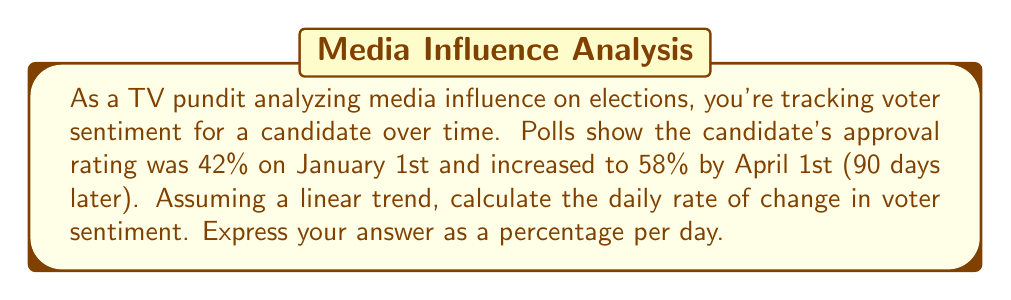Solve this math problem. To solve this problem, we'll use the concept of linear functions and rate of change. Let's break it down step-by-step:

1. Identify the given information:
   - Initial approval rating: 42% on January 1st
   - Final approval rating: 58% on April 1st
   - Time period: 90 days

2. Calculate the total change in approval rating:
   $\Delta y = 58\% - 42\% = 16\%$

3. Set up the rate of change formula:
   Rate of change = $\frac{\text{Change in y}}{\text{Change in x}} = \frac{\Delta y}{\Delta x}$

4. Plug in the values:
   Rate of change = $\frac{16\%}{90 \text{ days}}$

5. Perform the division:
   $\frac{16\%}{90} = \frac{16}{90} \% \approx 0.1778\%$ per day

Therefore, the daily rate of change in voter sentiment is approximately 0.1778% per day.
Answer: $0.1778\%$ per day 